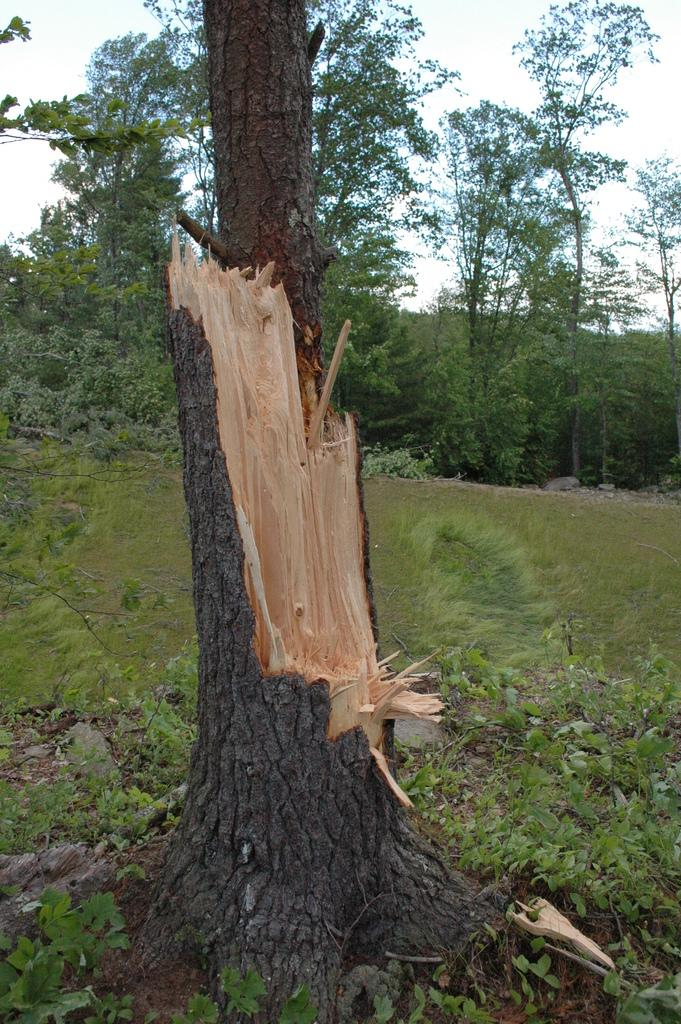Where was the image taken? The image was clicked outside. What is located in the front of the image? There is a tree in the front of the image. What type of vegetation is at the bottom of the image? There are small plants at the bottom of the image. What can be seen in the background of the image? There are trees in the background of the image. What is visible at the top of the image? The sky is visible at the top of the image. What type of silk is draped over the tree in the image? There is no silk present in the image; it features a tree and other vegetation. 